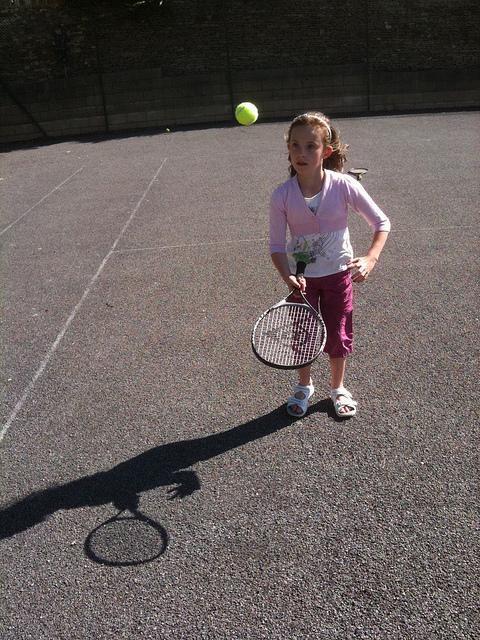How many balls are visible?
Give a very brief answer. 1. 